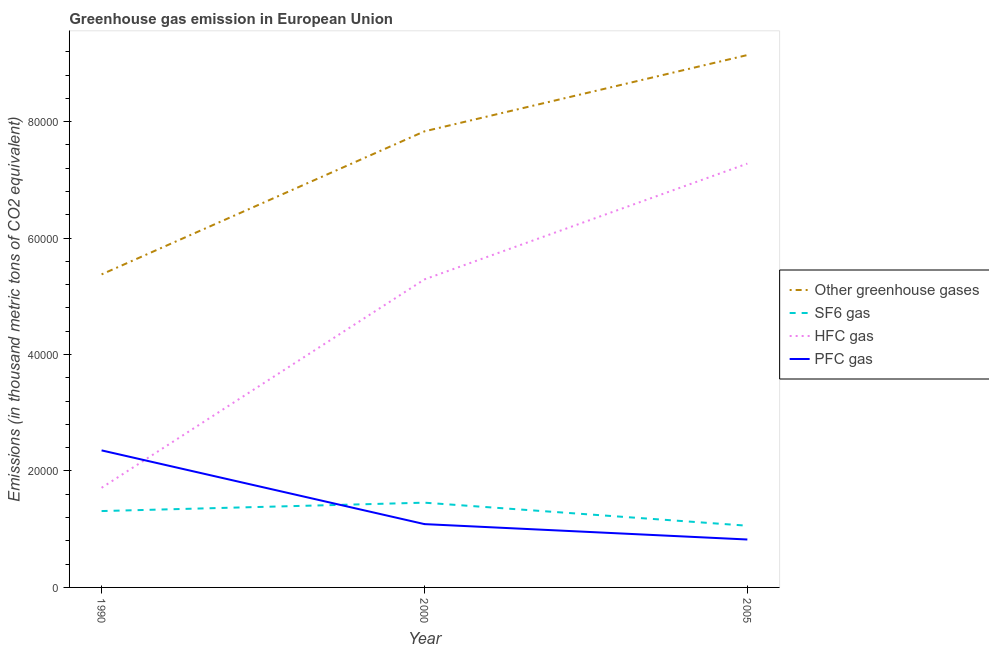Does the line corresponding to emission of sf6 gas intersect with the line corresponding to emission of pfc gas?
Your answer should be very brief. Yes. Is the number of lines equal to the number of legend labels?
Make the answer very short. Yes. What is the emission of greenhouse gases in 1990?
Give a very brief answer. 5.38e+04. Across all years, what is the maximum emission of pfc gas?
Keep it short and to the point. 2.35e+04. Across all years, what is the minimum emission of greenhouse gases?
Provide a short and direct response. 5.38e+04. What is the total emission of greenhouse gases in the graph?
Give a very brief answer. 2.24e+05. What is the difference between the emission of hfc gas in 1990 and that in 2005?
Ensure brevity in your answer.  -5.57e+04. What is the difference between the emission of hfc gas in 2000 and the emission of sf6 gas in 2005?
Your answer should be very brief. 4.23e+04. What is the average emission of pfc gas per year?
Keep it short and to the point. 1.42e+04. In the year 2005, what is the difference between the emission of sf6 gas and emission of hfc gas?
Your answer should be compact. -6.22e+04. What is the ratio of the emission of greenhouse gases in 2000 to that in 2005?
Offer a very short reply. 0.86. Is the difference between the emission of sf6 gas in 1990 and 2000 greater than the difference between the emission of greenhouse gases in 1990 and 2000?
Offer a very short reply. Yes. What is the difference between the highest and the second highest emission of hfc gas?
Your response must be concise. 1.99e+04. What is the difference between the highest and the lowest emission of hfc gas?
Provide a short and direct response. 5.57e+04. In how many years, is the emission of greenhouse gases greater than the average emission of greenhouse gases taken over all years?
Make the answer very short. 2. Is it the case that in every year, the sum of the emission of greenhouse gases and emission of sf6 gas is greater than the emission of hfc gas?
Your answer should be very brief. Yes. How many lines are there?
Your response must be concise. 4. How many years are there in the graph?
Provide a succinct answer. 3. What is the difference between two consecutive major ticks on the Y-axis?
Offer a terse response. 2.00e+04. Are the values on the major ticks of Y-axis written in scientific E-notation?
Offer a very short reply. No. Does the graph contain any zero values?
Make the answer very short. No. Does the graph contain grids?
Provide a short and direct response. No. Where does the legend appear in the graph?
Provide a short and direct response. Center right. How many legend labels are there?
Make the answer very short. 4. What is the title of the graph?
Keep it short and to the point. Greenhouse gas emission in European Union. Does "Primary education" appear as one of the legend labels in the graph?
Your answer should be compact. No. What is the label or title of the Y-axis?
Keep it short and to the point. Emissions (in thousand metric tons of CO2 equivalent). What is the Emissions (in thousand metric tons of CO2 equivalent) in Other greenhouse gases in 1990?
Offer a terse response. 5.38e+04. What is the Emissions (in thousand metric tons of CO2 equivalent) in SF6 gas in 1990?
Provide a short and direct response. 1.31e+04. What is the Emissions (in thousand metric tons of CO2 equivalent) in HFC gas in 1990?
Your answer should be very brief. 1.71e+04. What is the Emissions (in thousand metric tons of CO2 equivalent) in PFC gas in 1990?
Your answer should be very brief. 2.35e+04. What is the Emissions (in thousand metric tons of CO2 equivalent) in Other greenhouse gases in 2000?
Your answer should be very brief. 7.83e+04. What is the Emissions (in thousand metric tons of CO2 equivalent) in SF6 gas in 2000?
Provide a short and direct response. 1.46e+04. What is the Emissions (in thousand metric tons of CO2 equivalent) of HFC gas in 2000?
Offer a terse response. 5.29e+04. What is the Emissions (in thousand metric tons of CO2 equivalent) of PFC gas in 2000?
Provide a short and direct response. 1.09e+04. What is the Emissions (in thousand metric tons of CO2 equivalent) in Other greenhouse gases in 2005?
Offer a terse response. 9.14e+04. What is the Emissions (in thousand metric tons of CO2 equivalent) in SF6 gas in 2005?
Offer a very short reply. 1.06e+04. What is the Emissions (in thousand metric tons of CO2 equivalent) in HFC gas in 2005?
Offer a very short reply. 7.28e+04. What is the Emissions (in thousand metric tons of CO2 equivalent) of PFC gas in 2005?
Make the answer very short. 8230.79. Across all years, what is the maximum Emissions (in thousand metric tons of CO2 equivalent) of Other greenhouse gases?
Offer a very short reply. 9.14e+04. Across all years, what is the maximum Emissions (in thousand metric tons of CO2 equivalent) of SF6 gas?
Offer a terse response. 1.46e+04. Across all years, what is the maximum Emissions (in thousand metric tons of CO2 equivalent) of HFC gas?
Provide a succinct answer. 7.28e+04. Across all years, what is the maximum Emissions (in thousand metric tons of CO2 equivalent) of PFC gas?
Keep it short and to the point. 2.35e+04. Across all years, what is the minimum Emissions (in thousand metric tons of CO2 equivalent) in Other greenhouse gases?
Your response must be concise. 5.38e+04. Across all years, what is the minimum Emissions (in thousand metric tons of CO2 equivalent) in SF6 gas?
Ensure brevity in your answer.  1.06e+04. Across all years, what is the minimum Emissions (in thousand metric tons of CO2 equivalent) of HFC gas?
Give a very brief answer. 1.71e+04. Across all years, what is the minimum Emissions (in thousand metric tons of CO2 equivalent) of PFC gas?
Your response must be concise. 8230.79. What is the total Emissions (in thousand metric tons of CO2 equivalent) in Other greenhouse gases in the graph?
Make the answer very short. 2.24e+05. What is the total Emissions (in thousand metric tons of CO2 equivalent) in SF6 gas in the graph?
Keep it short and to the point. 3.83e+04. What is the total Emissions (in thousand metric tons of CO2 equivalent) of HFC gas in the graph?
Give a very brief answer. 1.43e+05. What is the total Emissions (in thousand metric tons of CO2 equivalent) in PFC gas in the graph?
Your answer should be compact. 4.26e+04. What is the difference between the Emissions (in thousand metric tons of CO2 equivalent) in Other greenhouse gases in 1990 and that in 2000?
Provide a short and direct response. -2.46e+04. What is the difference between the Emissions (in thousand metric tons of CO2 equivalent) of SF6 gas in 1990 and that in 2000?
Ensure brevity in your answer.  -1440.2. What is the difference between the Emissions (in thousand metric tons of CO2 equivalent) in HFC gas in 1990 and that in 2000?
Provide a succinct answer. -3.58e+04. What is the difference between the Emissions (in thousand metric tons of CO2 equivalent) of PFC gas in 1990 and that in 2000?
Your answer should be very brief. 1.27e+04. What is the difference between the Emissions (in thousand metric tons of CO2 equivalent) in Other greenhouse gases in 1990 and that in 2005?
Keep it short and to the point. -3.77e+04. What is the difference between the Emissions (in thousand metric tons of CO2 equivalent) in SF6 gas in 1990 and that in 2005?
Offer a terse response. 2517.88. What is the difference between the Emissions (in thousand metric tons of CO2 equivalent) in HFC gas in 1990 and that in 2005?
Your response must be concise. -5.57e+04. What is the difference between the Emissions (in thousand metric tons of CO2 equivalent) of PFC gas in 1990 and that in 2005?
Offer a terse response. 1.53e+04. What is the difference between the Emissions (in thousand metric tons of CO2 equivalent) in Other greenhouse gases in 2000 and that in 2005?
Ensure brevity in your answer.  -1.31e+04. What is the difference between the Emissions (in thousand metric tons of CO2 equivalent) of SF6 gas in 2000 and that in 2005?
Your answer should be compact. 3958.08. What is the difference between the Emissions (in thousand metric tons of CO2 equivalent) in HFC gas in 2000 and that in 2005?
Make the answer very short. -1.99e+04. What is the difference between the Emissions (in thousand metric tons of CO2 equivalent) of PFC gas in 2000 and that in 2005?
Provide a short and direct response. 2643.81. What is the difference between the Emissions (in thousand metric tons of CO2 equivalent) of Other greenhouse gases in 1990 and the Emissions (in thousand metric tons of CO2 equivalent) of SF6 gas in 2000?
Make the answer very short. 3.92e+04. What is the difference between the Emissions (in thousand metric tons of CO2 equivalent) of Other greenhouse gases in 1990 and the Emissions (in thousand metric tons of CO2 equivalent) of HFC gas in 2000?
Your answer should be very brief. 859.6. What is the difference between the Emissions (in thousand metric tons of CO2 equivalent) in Other greenhouse gases in 1990 and the Emissions (in thousand metric tons of CO2 equivalent) in PFC gas in 2000?
Your answer should be compact. 4.29e+04. What is the difference between the Emissions (in thousand metric tons of CO2 equivalent) of SF6 gas in 1990 and the Emissions (in thousand metric tons of CO2 equivalent) of HFC gas in 2000?
Your answer should be compact. -3.98e+04. What is the difference between the Emissions (in thousand metric tons of CO2 equivalent) in SF6 gas in 1990 and the Emissions (in thousand metric tons of CO2 equivalent) in PFC gas in 2000?
Offer a terse response. 2241.9. What is the difference between the Emissions (in thousand metric tons of CO2 equivalent) in HFC gas in 1990 and the Emissions (in thousand metric tons of CO2 equivalent) in PFC gas in 2000?
Your answer should be compact. 6235.6. What is the difference between the Emissions (in thousand metric tons of CO2 equivalent) in Other greenhouse gases in 1990 and the Emissions (in thousand metric tons of CO2 equivalent) in SF6 gas in 2005?
Provide a short and direct response. 4.32e+04. What is the difference between the Emissions (in thousand metric tons of CO2 equivalent) of Other greenhouse gases in 1990 and the Emissions (in thousand metric tons of CO2 equivalent) of HFC gas in 2005?
Your answer should be compact. -1.90e+04. What is the difference between the Emissions (in thousand metric tons of CO2 equivalent) of Other greenhouse gases in 1990 and the Emissions (in thousand metric tons of CO2 equivalent) of PFC gas in 2005?
Offer a very short reply. 4.55e+04. What is the difference between the Emissions (in thousand metric tons of CO2 equivalent) in SF6 gas in 1990 and the Emissions (in thousand metric tons of CO2 equivalent) in HFC gas in 2005?
Provide a succinct answer. -5.97e+04. What is the difference between the Emissions (in thousand metric tons of CO2 equivalent) of SF6 gas in 1990 and the Emissions (in thousand metric tons of CO2 equivalent) of PFC gas in 2005?
Offer a very short reply. 4885.71. What is the difference between the Emissions (in thousand metric tons of CO2 equivalent) of HFC gas in 1990 and the Emissions (in thousand metric tons of CO2 equivalent) of PFC gas in 2005?
Give a very brief answer. 8879.41. What is the difference between the Emissions (in thousand metric tons of CO2 equivalent) in Other greenhouse gases in 2000 and the Emissions (in thousand metric tons of CO2 equivalent) in SF6 gas in 2005?
Provide a short and direct response. 6.77e+04. What is the difference between the Emissions (in thousand metric tons of CO2 equivalent) of Other greenhouse gases in 2000 and the Emissions (in thousand metric tons of CO2 equivalent) of HFC gas in 2005?
Offer a very short reply. 5543.7. What is the difference between the Emissions (in thousand metric tons of CO2 equivalent) of Other greenhouse gases in 2000 and the Emissions (in thousand metric tons of CO2 equivalent) of PFC gas in 2005?
Give a very brief answer. 7.01e+04. What is the difference between the Emissions (in thousand metric tons of CO2 equivalent) of SF6 gas in 2000 and the Emissions (in thousand metric tons of CO2 equivalent) of HFC gas in 2005?
Offer a terse response. -5.82e+04. What is the difference between the Emissions (in thousand metric tons of CO2 equivalent) of SF6 gas in 2000 and the Emissions (in thousand metric tons of CO2 equivalent) of PFC gas in 2005?
Offer a terse response. 6325.91. What is the difference between the Emissions (in thousand metric tons of CO2 equivalent) in HFC gas in 2000 and the Emissions (in thousand metric tons of CO2 equivalent) in PFC gas in 2005?
Offer a terse response. 4.47e+04. What is the average Emissions (in thousand metric tons of CO2 equivalent) in Other greenhouse gases per year?
Ensure brevity in your answer.  7.45e+04. What is the average Emissions (in thousand metric tons of CO2 equivalent) in SF6 gas per year?
Provide a short and direct response. 1.28e+04. What is the average Emissions (in thousand metric tons of CO2 equivalent) of HFC gas per year?
Your answer should be very brief. 4.76e+04. What is the average Emissions (in thousand metric tons of CO2 equivalent) of PFC gas per year?
Your answer should be very brief. 1.42e+04. In the year 1990, what is the difference between the Emissions (in thousand metric tons of CO2 equivalent) in Other greenhouse gases and Emissions (in thousand metric tons of CO2 equivalent) in SF6 gas?
Make the answer very short. 4.06e+04. In the year 1990, what is the difference between the Emissions (in thousand metric tons of CO2 equivalent) of Other greenhouse gases and Emissions (in thousand metric tons of CO2 equivalent) of HFC gas?
Ensure brevity in your answer.  3.67e+04. In the year 1990, what is the difference between the Emissions (in thousand metric tons of CO2 equivalent) of Other greenhouse gases and Emissions (in thousand metric tons of CO2 equivalent) of PFC gas?
Your answer should be very brief. 3.02e+04. In the year 1990, what is the difference between the Emissions (in thousand metric tons of CO2 equivalent) in SF6 gas and Emissions (in thousand metric tons of CO2 equivalent) in HFC gas?
Offer a very short reply. -3993.7. In the year 1990, what is the difference between the Emissions (in thousand metric tons of CO2 equivalent) of SF6 gas and Emissions (in thousand metric tons of CO2 equivalent) of PFC gas?
Offer a terse response. -1.04e+04. In the year 1990, what is the difference between the Emissions (in thousand metric tons of CO2 equivalent) in HFC gas and Emissions (in thousand metric tons of CO2 equivalent) in PFC gas?
Make the answer very short. -6426.3. In the year 2000, what is the difference between the Emissions (in thousand metric tons of CO2 equivalent) of Other greenhouse gases and Emissions (in thousand metric tons of CO2 equivalent) of SF6 gas?
Provide a short and direct response. 6.38e+04. In the year 2000, what is the difference between the Emissions (in thousand metric tons of CO2 equivalent) in Other greenhouse gases and Emissions (in thousand metric tons of CO2 equivalent) in HFC gas?
Offer a very short reply. 2.54e+04. In the year 2000, what is the difference between the Emissions (in thousand metric tons of CO2 equivalent) in Other greenhouse gases and Emissions (in thousand metric tons of CO2 equivalent) in PFC gas?
Make the answer very short. 6.75e+04. In the year 2000, what is the difference between the Emissions (in thousand metric tons of CO2 equivalent) of SF6 gas and Emissions (in thousand metric tons of CO2 equivalent) of HFC gas?
Ensure brevity in your answer.  -3.83e+04. In the year 2000, what is the difference between the Emissions (in thousand metric tons of CO2 equivalent) of SF6 gas and Emissions (in thousand metric tons of CO2 equivalent) of PFC gas?
Your answer should be compact. 3682.1. In the year 2000, what is the difference between the Emissions (in thousand metric tons of CO2 equivalent) of HFC gas and Emissions (in thousand metric tons of CO2 equivalent) of PFC gas?
Offer a very short reply. 4.20e+04. In the year 2005, what is the difference between the Emissions (in thousand metric tons of CO2 equivalent) in Other greenhouse gases and Emissions (in thousand metric tons of CO2 equivalent) in SF6 gas?
Your answer should be very brief. 8.08e+04. In the year 2005, what is the difference between the Emissions (in thousand metric tons of CO2 equivalent) in Other greenhouse gases and Emissions (in thousand metric tons of CO2 equivalent) in HFC gas?
Provide a succinct answer. 1.86e+04. In the year 2005, what is the difference between the Emissions (in thousand metric tons of CO2 equivalent) in Other greenhouse gases and Emissions (in thousand metric tons of CO2 equivalent) in PFC gas?
Give a very brief answer. 8.32e+04. In the year 2005, what is the difference between the Emissions (in thousand metric tons of CO2 equivalent) of SF6 gas and Emissions (in thousand metric tons of CO2 equivalent) of HFC gas?
Offer a very short reply. -6.22e+04. In the year 2005, what is the difference between the Emissions (in thousand metric tons of CO2 equivalent) in SF6 gas and Emissions (in thousand metric tons of CO2 equivalent) in PFC gas?
Provide a succinct answer. 2367.83. In the year 2005, what is the difference between the Emissions (in thousand metric tons of CO2 equivalent) in HFC gas and Emissions (in thousand metric tons of CO2 equivalent) in PFC gas?
Your response must be concise. 6.46e+04. What is the ratio of the Emissions (in thousand metric tons of CO2 equivalent) of Other greenhouse gases in 1990 to that in 2000?
Provide a short and direct response. 0.69. What is the ratio of the Emissions (in thousand metric tons of CO2 equivalent) in SF6 gas in 1990 to that in 2000?
Ensure brevity in your answer.  0.9. What is the ratio of the Emissions (in thousand metric tons of CO2 equivalent) in HFC gas in 1990 to that in 2000?
Your answer should be very brief. 0.32. What is the ratio of the Emissions (in thousand metric tons of CO2 equivalent) in PFC gas in 1990 to that in 2000?
Give a very brief answer. 2.16. What is the ratio of the Emissions (in thousand metric tons of CO2 equivalent) in Other greenhouse gases in 1990 to that in 2005?
Offer a terse response. 0.59. What is the ratio of the Emissions (in thousand metric tons of CO2 equivalent) in SF6 gas in 1990 to that in 2005?
Offer a terse response. 1.24. What is the ratio of the Emissions (in thousand metric tons of CO2 equivalent) in HFC gas in 1990 to that in 2005?
Provide a succinct answer. 0.24. What is the ratio of the Emissions (in thousand metric tons of CO2 equivalent) in PFC gas in 1990 to that in 2005?
Your answer should be compact. 2.86. What is the ratio of the Emissions (in thousand metric tons of CO2 equivalent) of Other greenhouse gases in 2000 to that in 2005?
Give a very brief answer. 0.86. What is the ratio of the Emissions (in thousand metric tons of CO2 equivalent) of SF6 gas in 2000 to that in 2005?
Your answer should be compact. 1.37. What is the ratio of the Emissions (in thousand metric tons of CO2 equivalent) in HFC gas in 2000 to that in 2005?
Keep it short and to the point. 0.73. What is the ratio of the Emissions (in thousand metric tons of CO2 equivalent) of PFC gas in 2000 to that in 2005?
Offer a terse response. 1.32. What is the difference between the highest and the second highest Emissions (in thousand metric tons of CO2 equivalent) of Other greenhouse gases?
Offer a very short reply. 1.31e+04. What is the difference between the highest and the second highest Emissions (in thousand metric tons of CO2 equivalent) in SF6 gas?
Keep it short and to the point. 1440.2. What is the difference between the highest and the second highest Emissions (in thousand metric tons of CO2 equivalent) of HFC gas?
Give a very brief answer. 1.99e+04. What is the difference between the highest and the second highest Emissions (in thousand metric tons of CO2 equivalent) of PFC gas?
Ensure brevity in your answer.  1.27e+04. What is the difference between the highest and the lowest Emissions (in thousand metric tons of CO2 equivalent) in Other greenhouse gases?
Ensure brevity in your answer.  3.77e+04. What is the difference between the highest and the lowest Emissions (in thousand metric tons of CO2 equivalent) of SF6 gas?
Provide a short and direct response. 3958.08. What is the difference between the highest and the lowest Emissions (in thousand metric tons of CO2 equivalent) in HFC gas?
Make the answer very short. 5.57e+04. What is the difference between the highest and the lowest Emissions (in thousand metric tons of CO2 equivalent) of PFC gas?
Provide a succinct answer. 1.53e+04. 